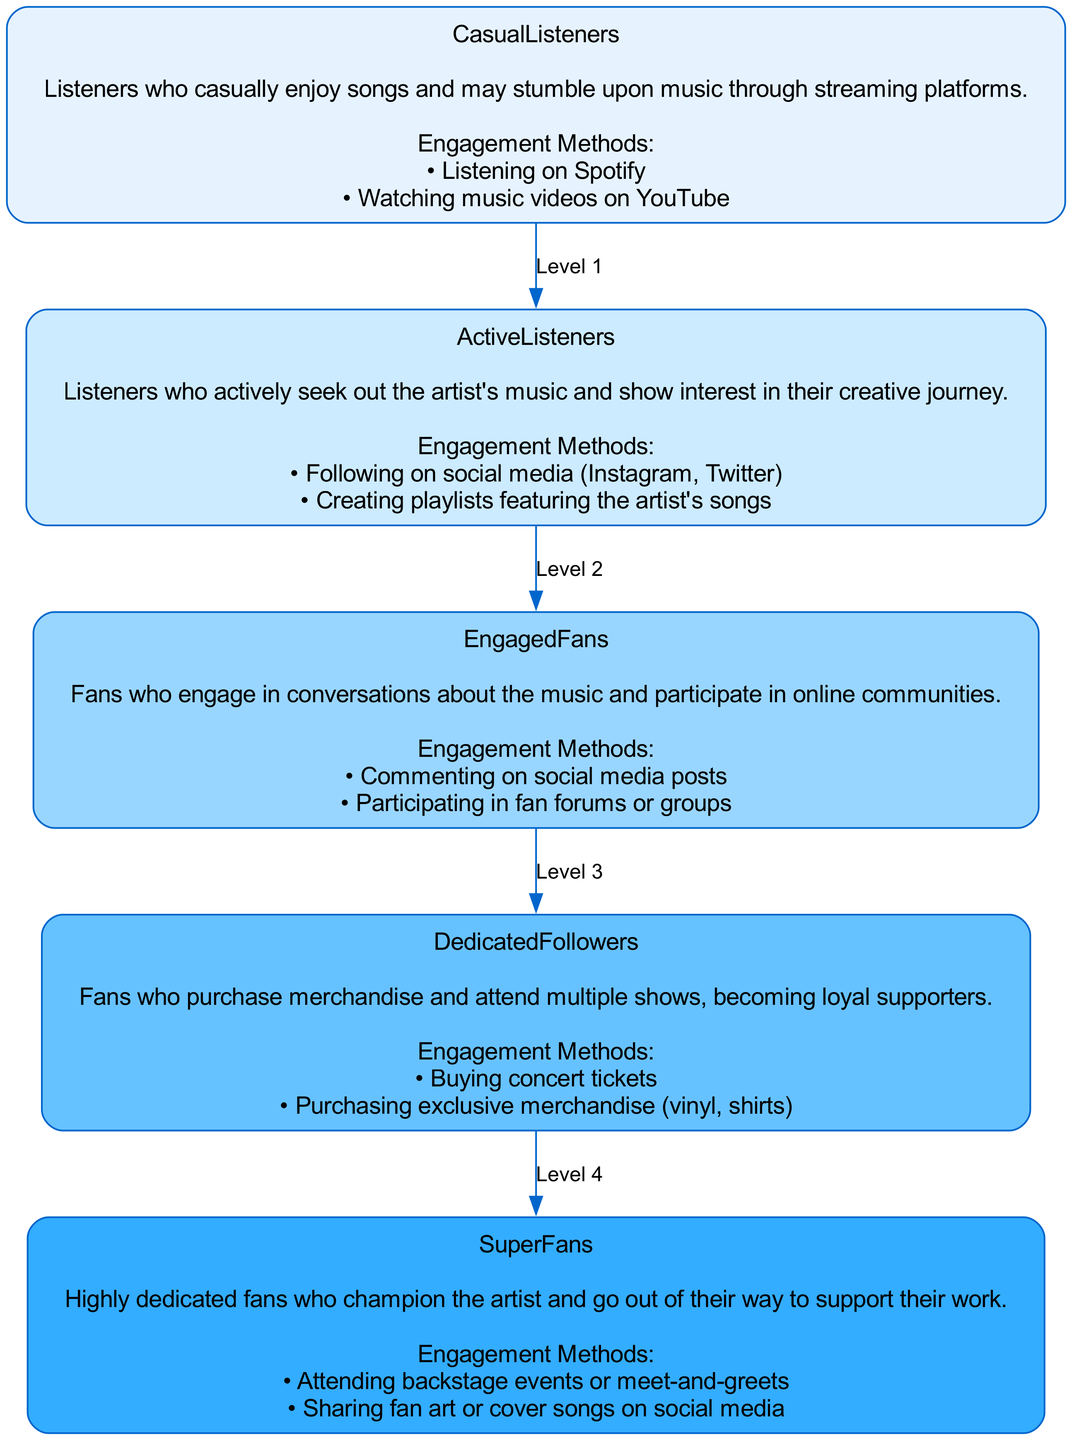What is the highest level of fan engagement? The highest level in the diagram is determined by identifying the node that symbolizes the most committed or supportive fans. In this case, the last node in the directed graph accordingly labeled is "SuperFans."
Answer: SuperFans How many engagement methods are listed for "EngagedFans"? To find this number, we look specifically at the "EngagedFans" node, counting the listed engagement methods. There are two methods mentioned: "Commenting on social media posts" and "Participating in fan forums or groups."
Answer: 2 Which level involves purchasing exclusive merchandise? This question directs us to locate which node includes activities or methods related to buying exclusive items. The "DedicatedFollowers" level is the one that specifies purchasing exclusive merchandise like vinyl and shirts.
Answer: DedicatedFollowers What is the direct relationship between "ActiveListeners" and "EngagedFans"? To find their relationship, examine the edges connected to these two nodes in the graph. "ActiveListeners" directly connects to "EngagedFans," following the flow of fan engagement, which indicates progression.
Answer: Level 2 What is the progression from "CasualListeners" to "SuperFans"? This progression entails identifying all intermediate levels between the starting point (CasualListeners) and the endpoint (SuperFans). The levels in order are: ActiveListeners, EngagedFans, DedicatedFollowers, then finally SuperFans.
Answer: ActiveListeners, EngagedFans, DedicatedFollowers, SuperFans How many total nodes are present in the diagram? The total count of nodes can be easily determined by identifying each labeled level of engagement within the diagram. There are five distinct levels in total: CasualListeners, ActiveListeners, EngagedFans, DedicatedFollowers, and SuperFans.
Answer: 5 Which engagement method is unique to "SuperFans"? To determine which method is specifically related to "SuperFans," examine the engagement methods listed for that node. "Attending backstage events or meet-and-greets" is mentioned as a method only for SuperFans, indicating a deeper level of engagement.
Answer: Attending backstage events or meet-and-greets How many edges are drawn in the diagram? This question involves counting the number of connections or edges between the nodes represented in the graph. Each connection symbolizes the flow from one fan level to the next, leading to a total of four edges in the directed graph that connect all levels.
Answer: 4 